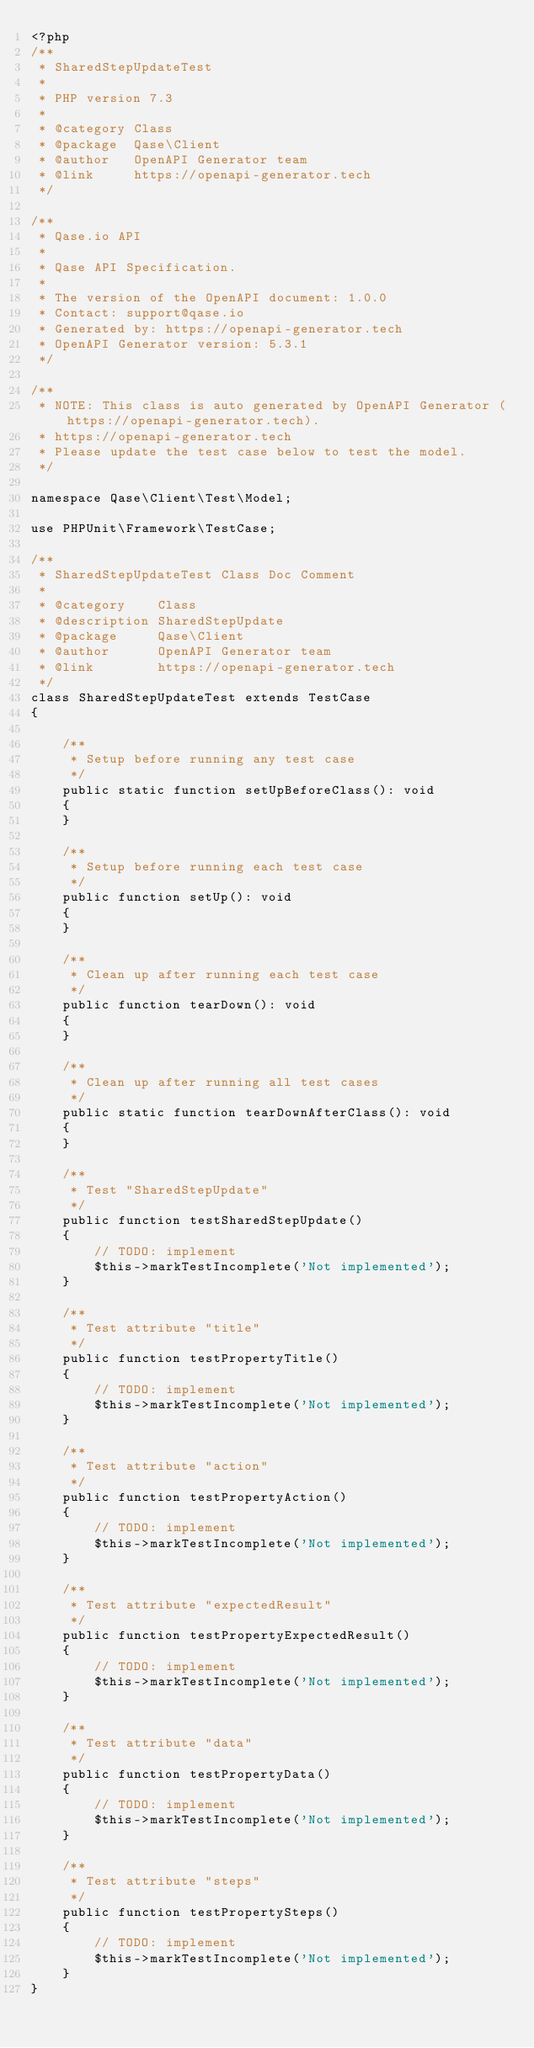<code> <loc_0><loc_0><loc_500><loc_500><_PHP_><?php
/**
 * SharedStepUpdateTest
 *
 * PHP version 7.3
 *
 * @category Class
 * @package  Qase\Client
 * @author   OpenAPI Generator team
 * @link     https://openapi-generator.tech
 */

/**
 * Qase.io API
 *
 * Qase API Specification.
 *
 * The version of the OpenAPI document: 1.0.0
 * Contact: support@qase.io
 * Generated by: https://openapi-generator.tech
 * OpenAPI Generator version: 5.3.1
 */

/**
 * NOTE: This class is auto generated by OpenAPI Generator (https://openapi-generator.tech).
 * https://openapi-generator.tech
 * Please update the test case below to test the model.
 */

namespace Qase\Client\Test\Model;

use PHPUnit\Framework\TestCase;

/**
 * SharedStepUpdateTest Class Doc Comment
 *
 * @category    Class
 * @description SharedStepUpdate
 * @package     Qase\Client
 * @author      OpenAPI Generator team
 * @link        https://openapi-generator.tech
 */
class SharedStepUpdateTest extends TestCase
{

    /**
     * Setup before running any test case
     */
    public static function setUpBeforeClass(): void
    {
    }

    /**
     * Setup before running each test case
     */
    public function setUp(): void
    {
    }

    /**
     * Clean up after running each test case
     */
    public function tearDown(): void
    {
    }

    /**
     * Clean up after running all test cases
     */
    public static function tearDownAfterClass(): void
    {
    }

    /**
     * Test "SharedStepUpdate"
     */
    public function testSharedStepUpdate()
    {
        // TODO: implement
        $this->markTestIncomplete('Not implemented');
    }

    /**
     * Test attribute "title"
     */
    public function testPropertyTitle()
    {
        // TODO: implement
        $this->markTestIncomplete('Not implemented');
    }

    /**
     * Test attribute "action"
     */
    public function testPropertyAction()
    {
        // TODO: implement
        $this->markTestIncomplete('Not implemented');
    }

    /**
     * Test attribute "expectedResult"
     */
    public function testPropertyExpectedResult()
    {
        // TODO: implement
        $this->markTestIncomplete('Not implemented');
    }

    /**
     * Test attribute "data"
     */
    public function testPropertyData()
    {
        // TODO: implement
        $this->markTestIncomplete('Not implemented');
    }

    /**
     * Test attribute "steps"
     */
    public function testPropertySteps()
    {
        // TODO: implement
        $this->markTestIncomplete('Not implemented');
    }
}
</code> 